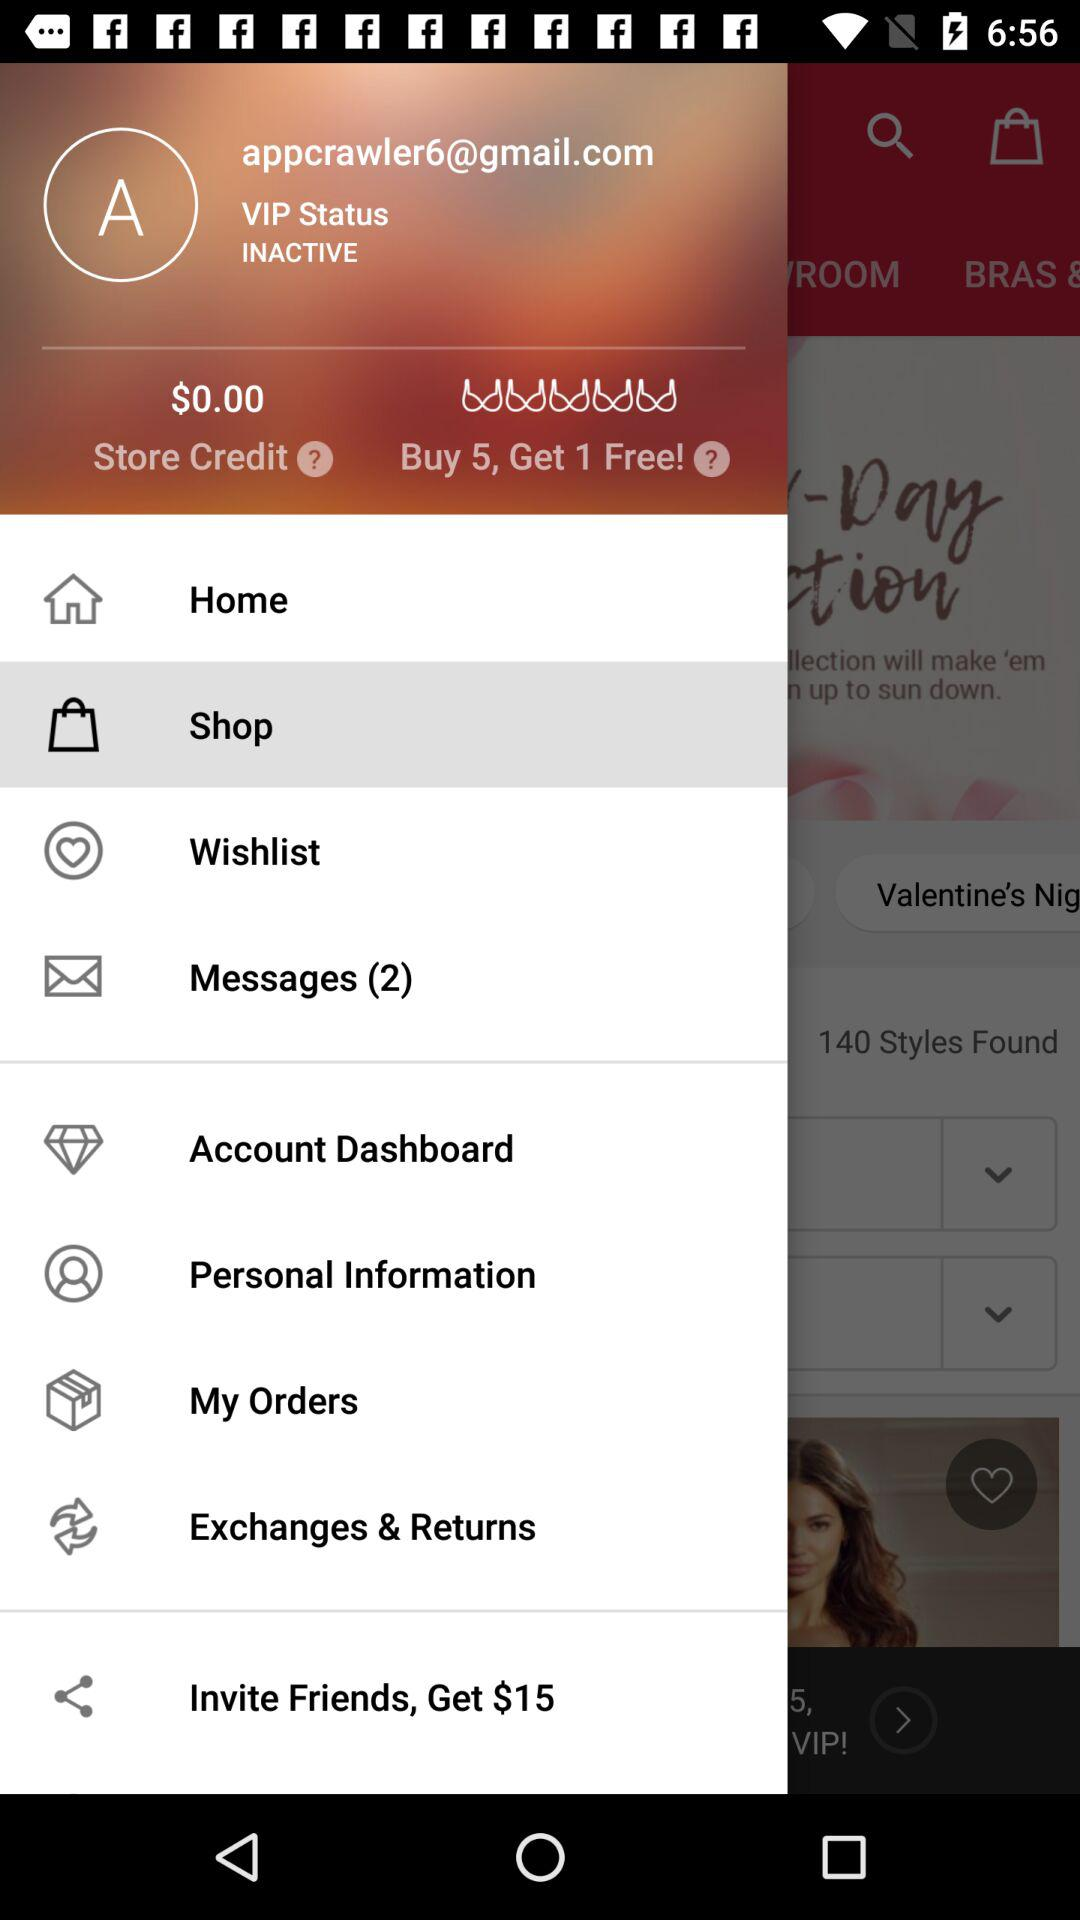After buying 5, how many do we get free? You get 1 free. 